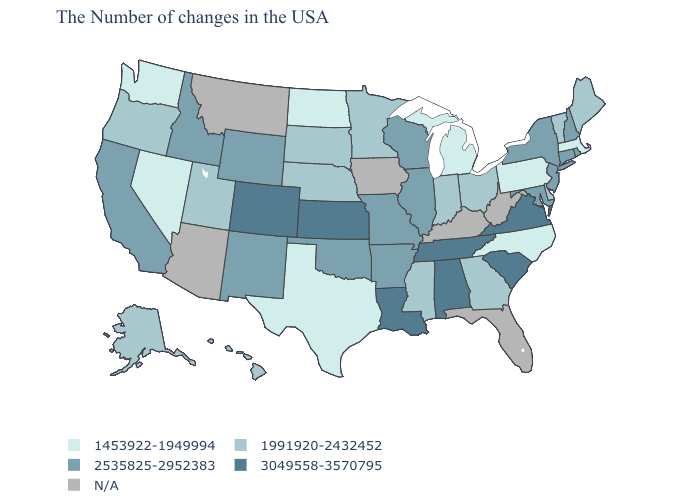Name the states that have a value in the range 1991920-2432452?
Answer briefly. Maine, Vermont, Delaware, Ohio, Georgia, Indiana, Mississippi, Minnesota, Nebraska, South Dakota, Utah, Oregon, Alaska, Hawaii. What is the highest value in the MidWest ?
Keep it brief. 3049558-3570795. Name the states that have a value in the range N/A?
Keep it brief. West Virginia, Florida, Kentucky, Iowa, Montana, Arizona. What is the value of Montana?
Give a very brief answer. N/A. What is the highest value in states that border Wyoming?
Answer briefly. 3049558-3570795. Is the legend a continuous bar?
Keep it brief. No. What is the highest value in the MidWest ?
Short answer required. 3049558-3570795. Name the states that have a value in the range N/A?
Answer briefly. West Virginia, Florida, Kentucky, Iowa, Montana, Arizona. What is the lowest value in the South?
Answer briefly. 1453922-1949994. Is the legend a continuous bar?
Keep it brief. No. What is the value of Hawaii?
Give a very brief answer. 1991920-2432452. Does the map have missing data?
Short answer required. Yes. What is the value of Oregon?
Be succinct. 1991920-2432452. 